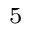Convert formula to latex. <formula><loc_0><loc_0><loc_500><loc_500>^ { 5 }</formula> 